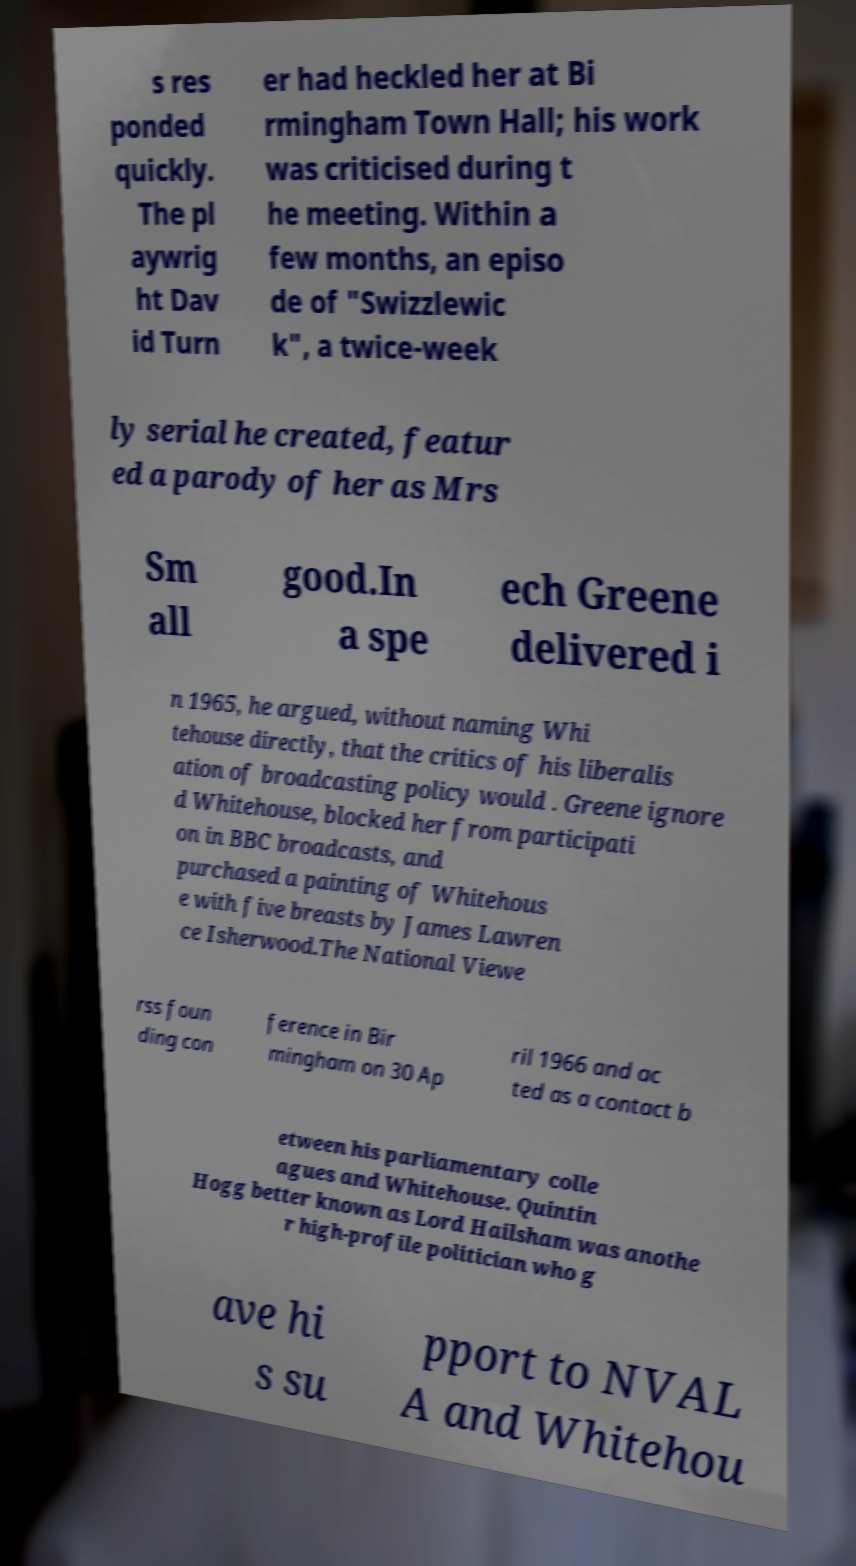Could you assist in decoding the text presented in this image and type it out clearly? s res ponded quickly. The pl aywrig ht Dav id Turn er had heckled her at Bi rmingham Town Hall; his work was criticised during t he meeting. Within a few months, an episo de of "Swizzlewic k", a twice-week ly serial he created, featur ed a parody of her as Mrs Sm all good.In a spe ech Greene delivered i n 1965, he argued, without naming Whi tehouse directly, that the critics of his liberalis ation of broadcasting policy would . Greene ignore d Whitehouse, blocked her from participati on in BBC broadcasts, and purchased a painting of Whitehous e with five breasts by James Lawren ce Isherwood.The National Viewe rss foun ding con ference in Bir mingham on 30 Ap ril 1966 and ac ted as a contact b etween his parliamentary colle agues and Whitehouse. Quintin Hogg better known as Lord Hailsham was anothe r high-profile politician who g ave hi s su pport to NVAL A and Whitehou 